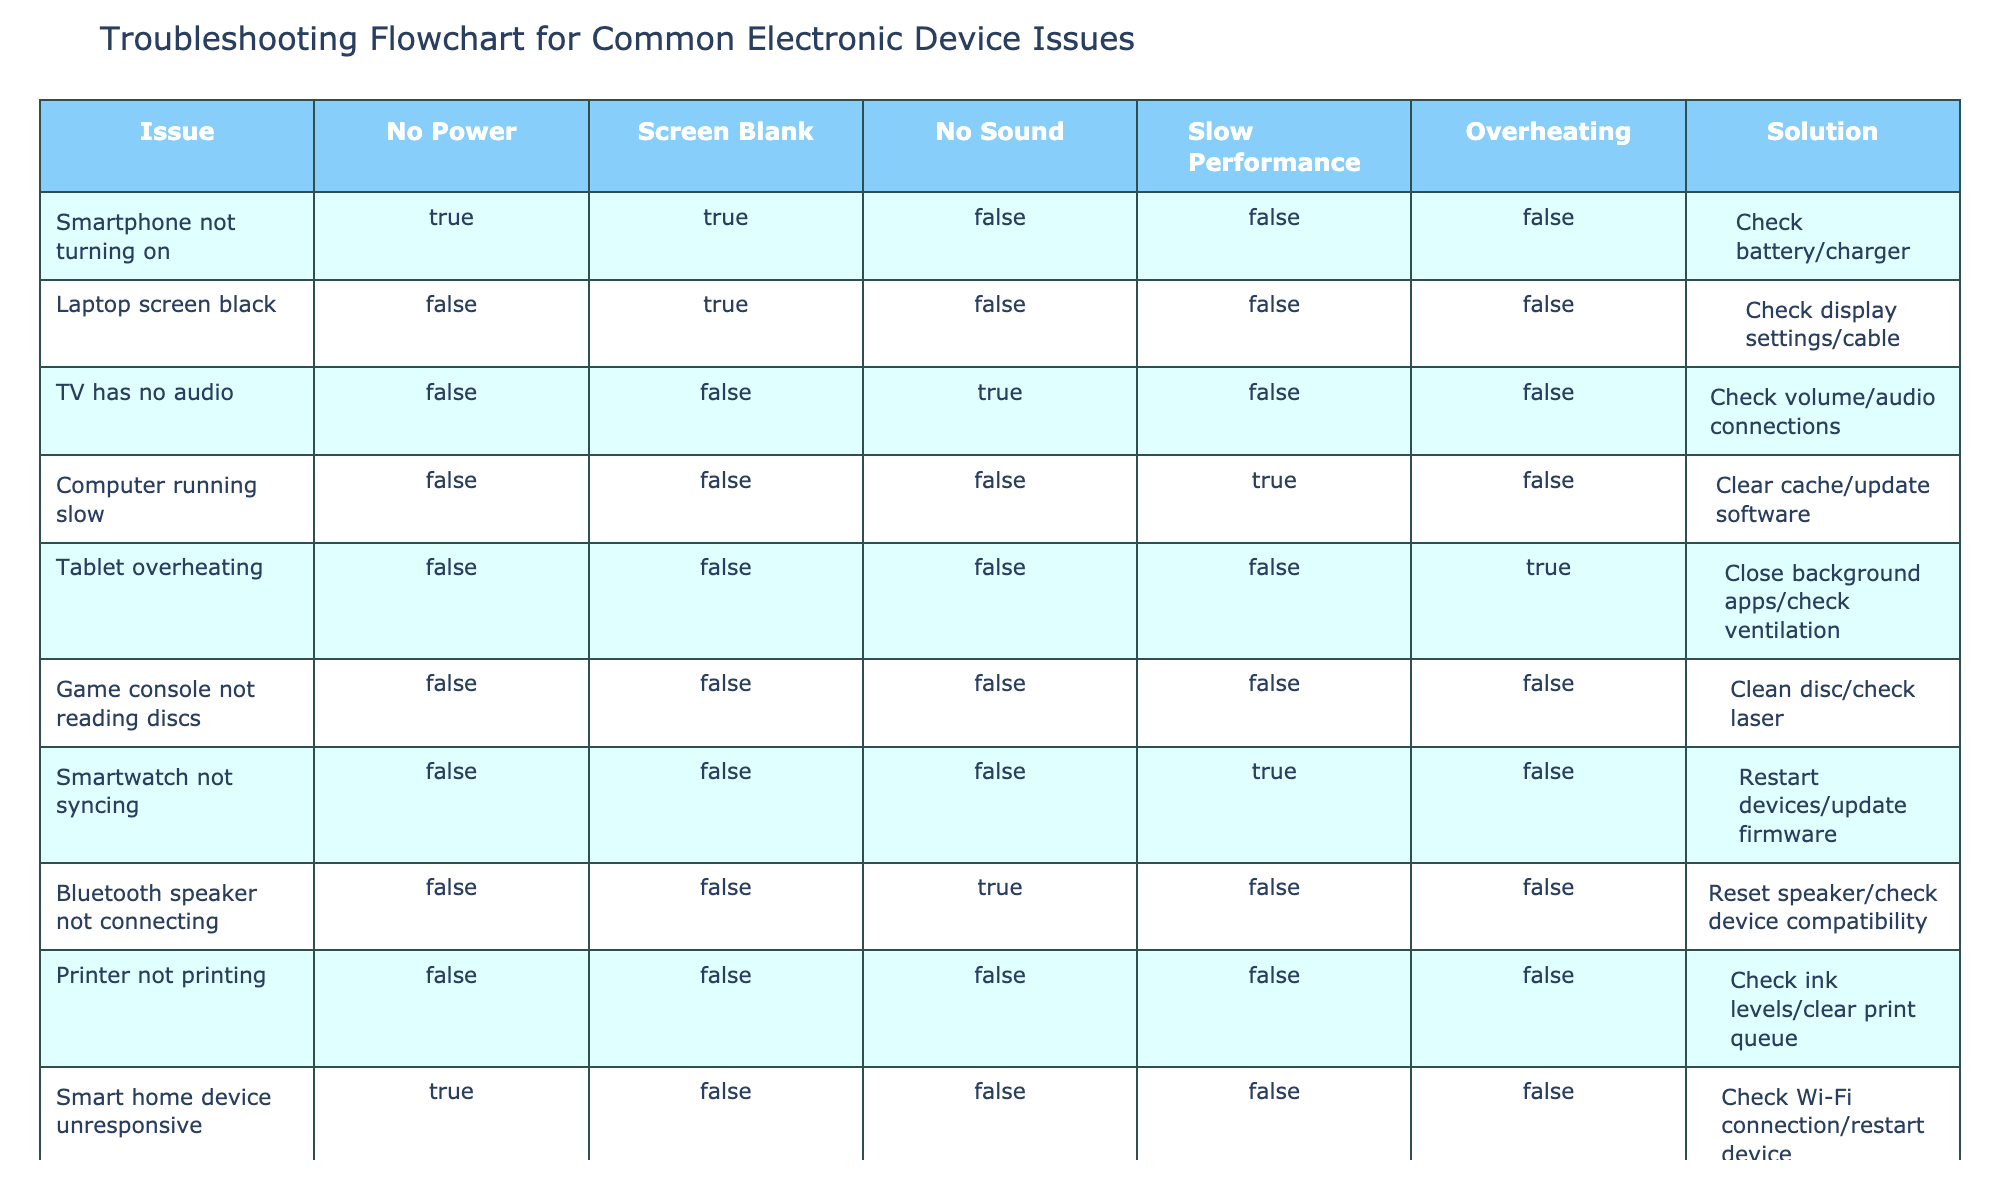What is the solution for a smartphone not turning on? According to the table, the solution provided for a smartphone not turning on is to check the battery or charger. This information can be found in the row corresponding to "Smartphone not turning on."
Answer: Check battery/charger How many issues in the table involve slow performance? The table lists one specific issue that involves slow performance, which is "Computer running slow." Since there's only one instance, the final tally is one.
Answer: 1 Is there an issue with a printer not printing? The data shows that there is an issue labeled "Printer not printing," and the row confirms the relevant details regarding this problem, thus confirming the question.
Answer: Yes What common solution appears for smart devices? Looking through the table, the problem "Smart home device unresponsive" mentions to check Wi-Fi connection/restart device, and similarly, "Smartwatch not syncing" suggests restarting devices/update firmware. The actions of restarting devices appear in different contexts, indicating that it's a common solution across multiple smart devices.
Answer: Restart devices Which issue has the solution of checking volume/audio connections? The issue linked to checking volume/audio connections is "TV has no audio." This can be directly identified from the related row in the table.
Answer: TV has no audio What outcome relates to slow performance when troubleshooting? The only outcome related to slow performance is under "Computer running slow," which indicates that the solution is to clear cache/update software. This means when the device runs slow, the recommended action is specifically mentioned.
Answer: Clear cache/update software Are there any issues related to overheating in the table? Within the table, there is one specific mention of an issue related to overheating, which is "Tablet overheating." This confirms that overheating is indeed included in the listed problems.
Answer: Yes What do you do if a Bluetooth speaker is not connecting? The table specifies that if a Bluetooth speaker is not connecting, the solution is to reset the speaker and check device compatibility. This is directly referenced in the row regarding the Bluetooth speaker.
Answer: Reset speaker/check device compatibility How many devices in the table have no power issues? Upon reviewing the table, there are three devices marked with the "No Power" issue: "Smartphone not turning on," and "Smart home device unresponsive." Counting them gives us two such devices.
Answer: 2 